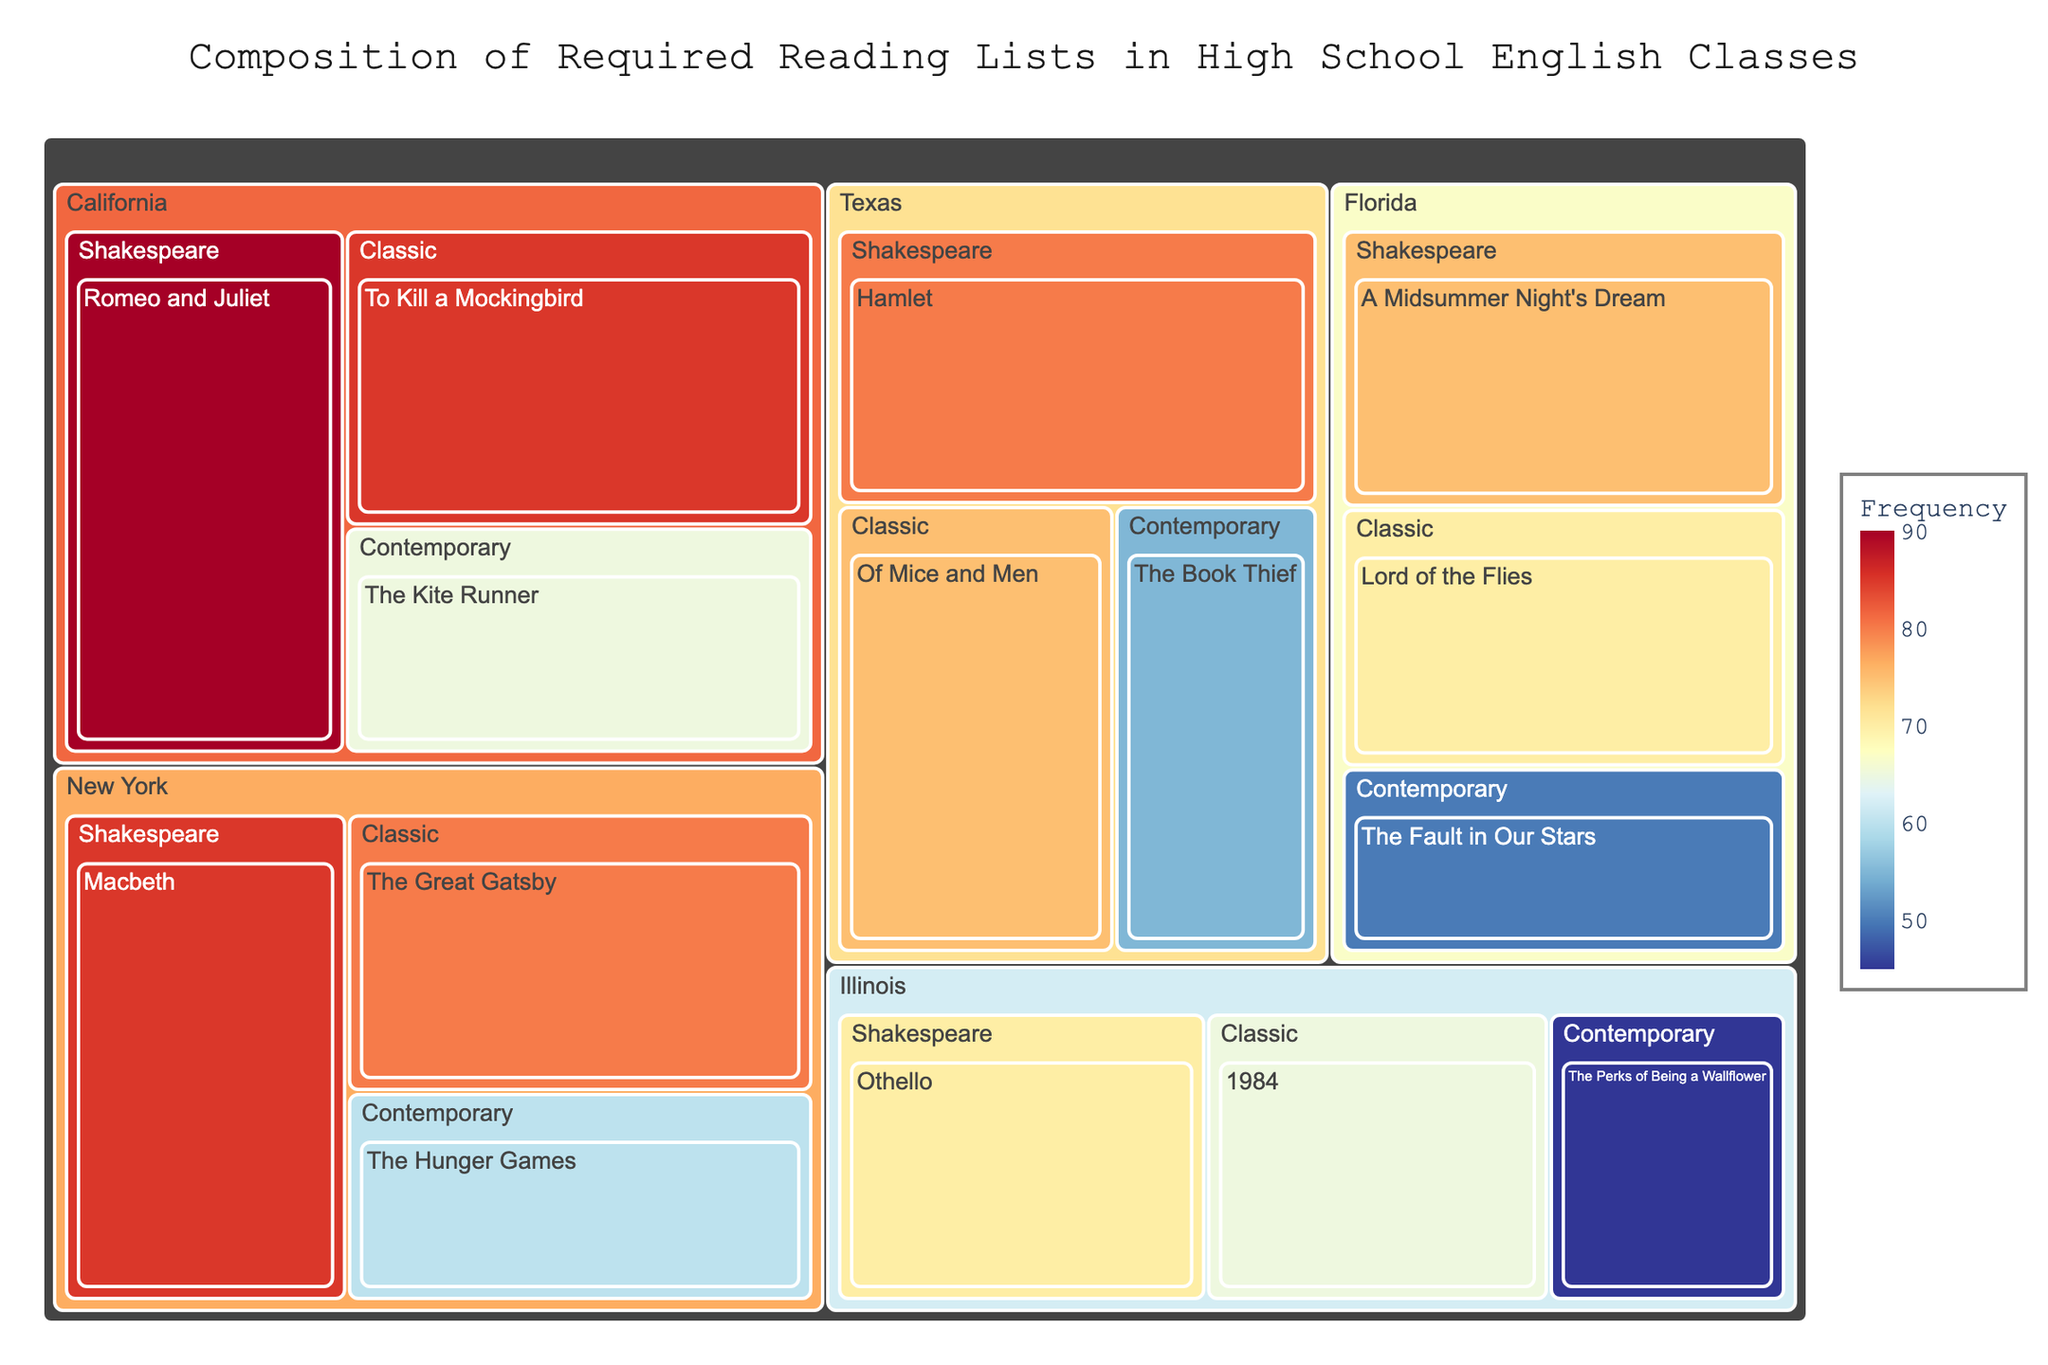What's the most frequently listed Shakespeare play in California? The treemap shows that in California, "Romeo and Juliet" has the highest frequency of 90 among the Shakespeare plays.
Answer: Romeo and Juliet Which state has "The Great Gatsby" on its reading list, and how often? The treemap reveals that "The Great Gatsby" is part of New York's reading list, with a frequency of 80.
Answer: New York, 80 How does the frequency of "1984" in Illinois compare to that of "Lord of the Flies" in Florida? "1984" in Illinois has a frequency of 65, while "Lord of the Flies" in Florida has a frequency of 70. Thus, "Lord of the Flies" is more frequently listed than "1984".
Answer: 1984: 65, Lord of the Flies: 70 Which genre has the highest frequency in Texas and what is the book? In Texas, the highest frequency in the treemap is under the Shakespeare genre, with "Hamlet" at a frequency of 80.
Answer: Shakespeare, Hamlet How does the frequency of contemporary books in California compare to that in New York? In California, the contemporary book "The Kite Runner" has a frequency of 65, whereas in New York, "The Hunger Games" has a frequency of 60. Thus, contemporary books are more frequently listed in California than in New York.
Answer: California: 65, New York: 60 What is the overall frequency of Shakespeare plays in all states combined? Adding up the frequencies for all Shakespeare plays: "Romeo and Juliet" (90), "Macbeth" (85), "Hamlet" (80), "A Midsummer Night's Dream" (75), and "Othello" (70). The total is 90 + 85 + 80 + 75 + 70 = 400.
Answer: 400 What is the most assigned classic book in New York and Florida combined? In New York, "The Great Gatsby" has a frequency of 80 and in Florida, "Lord of the Flies" has a frequency of 70. "The Great Gatsby" in New York has a higher frequency than "Lord of the Flies" in Florida.
Answer: The Great Gatsby Compare the presence of contemporary books in Texas and Illinois. Which state has more frequent inclusion of contemporary books? In Texas, the contemporary book "The Book Thief" has a frequency of 55 while in Illinois, "The Perks of Being a Wallflower" has a frequency of 45. Texas has a higher frequency for contemporary books than Illinois.
Answer: Texas: 55, Illinois: 45 Which genre appears most often overall across the states? Summing the frequencies of each genre across all states: 
- Classic: To Kill a Mockingbird (85) + The Great Gatsby (80) + Of Mice and Men (75) + Lord of the Flies (70) + 1984 (65) = 375
- Contemporary: The Kite Runner (65) + The Hunger Games (60) + The Book Thief (55) + The Fault in Our Stars (50) + The Perks of Being a Wallflower (45) = 275
- Shakespeare: Romeo and Juliet (90) + Macbeth (85) + Hamlet (80) + A Midsummer Night's Dream (75) + Othello (70) = 400
Thus, the Shakespeare genre has the highest overall frequency.
Answer: Shakespeare In California, which book has a higher frequency, "The Kite Runner" or "To Kill a Mockingbird"? In the treemap, "To Kill a Mockingbird" has a frequency of 85 and "The Kite Runner" has a frequency of 65. Therefore, "To Kill a Mockingbird" has a higher frequency.
Answer: To Kill a Mockingbird 